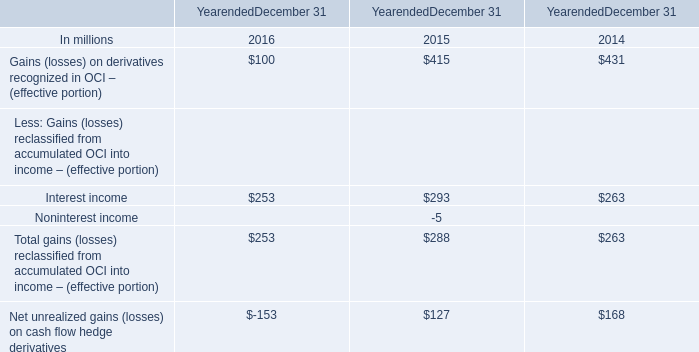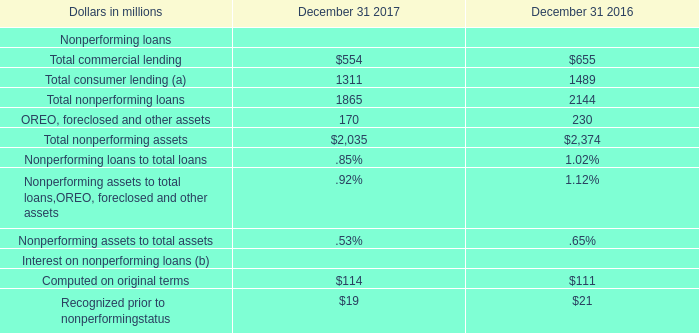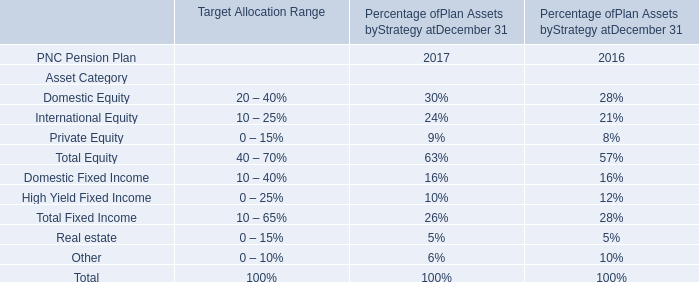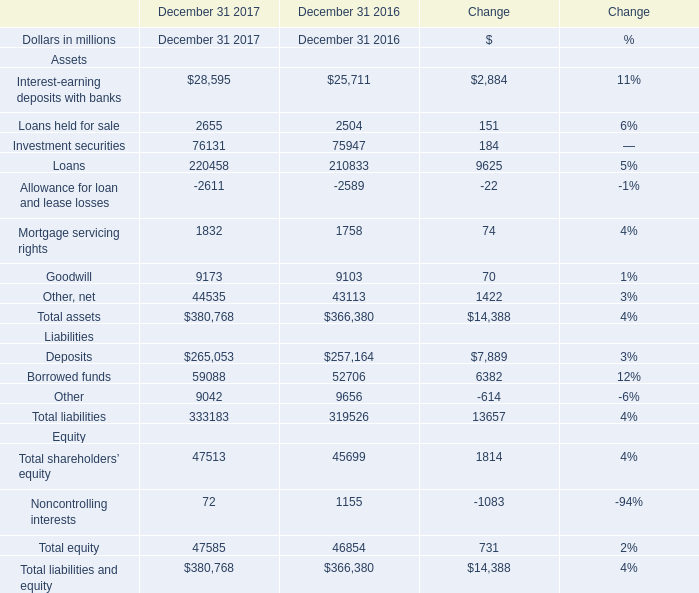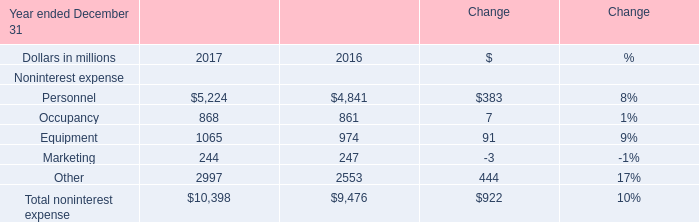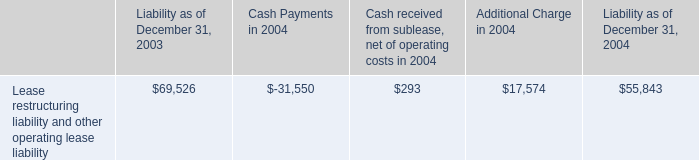In what year is Interest-earning deposits with banks greater than 1? 
Answer: December 31 2017 December 31 2016. 